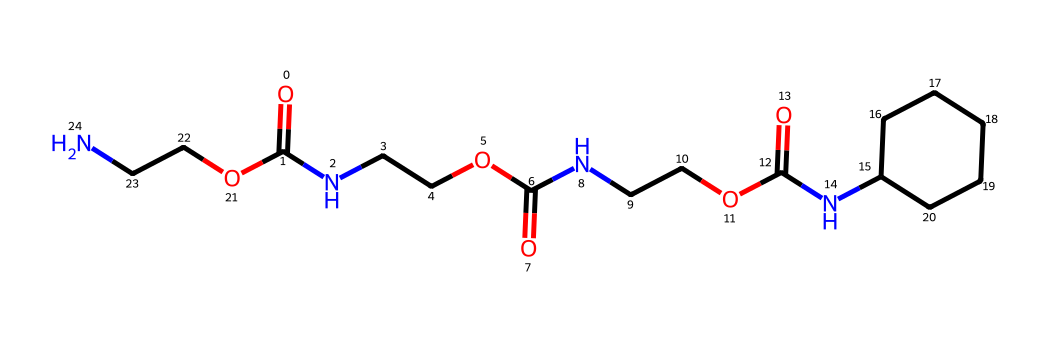how many carbon atoms are in the structure? To determine the number of carbon atoms, we can analyze the SMILES representation by counting all the occurrences of 'C'. Each 'C' represents a carbon atom. In this case, we see 13 carbon atoms.
Answer: 13 how many nitrogen atoms are present in this chemical? We look for the letter 'N' in the SMILES representation, as each 'N' corresponds to a nitrogen atom. There are 4 occurrences of 'N' in the structure.
Answer: 4 what type of functional groups can be identified in this chemical? The structure includes 'O=C', which indicates the presence of amides or carboxylic acid groups. Additionally, the presence of ether linkages is suggested by 'C(=O)NCCO'. So, we have amide and ether functional groups.
Answer: amide and ether which part of the chemical structure contributes to the flexibility of the material? The inclusion of carbon chains like 'C1CCCCC1' denotes an alkyl group, specifically a cycloalkane. This contributes to flexibility due to the presence of carbon-carbon single bonds allowing rotation around them.
Answer: cycloalkane how does this chemical promote enhanced grip in football cleat studs? The presence of amide and ether functional groups enhances thermal stability and flexibility in the rubber components of cleat studs. This allows the studs to better conform to varying surfaces, improving grip.
Answer: amide and ether functional groups 